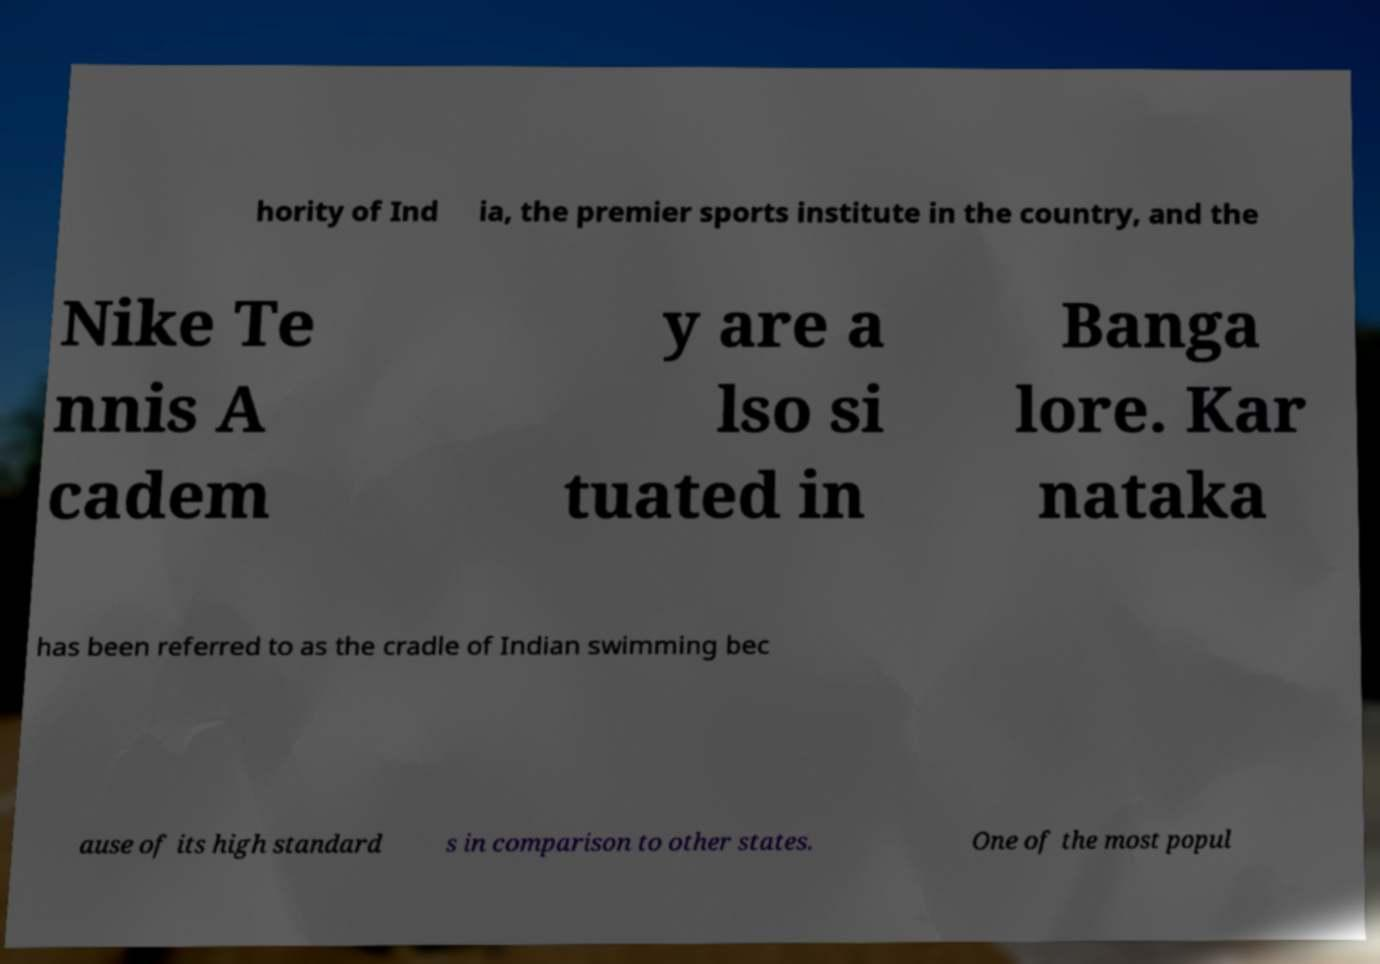Can you read and provide the text displayed in the image?This photo seems to have some interesting text. Can you extract and type it out for me? hority of Ind ia, the premier sports institute in the country, and the Nike Te nnis A cadem y are a lso si tuated in Banga lore. Kar nataka has been referred to as the cradle of Indian swimming bec ause of its high standard s in comparison to other states. One of the most popul 